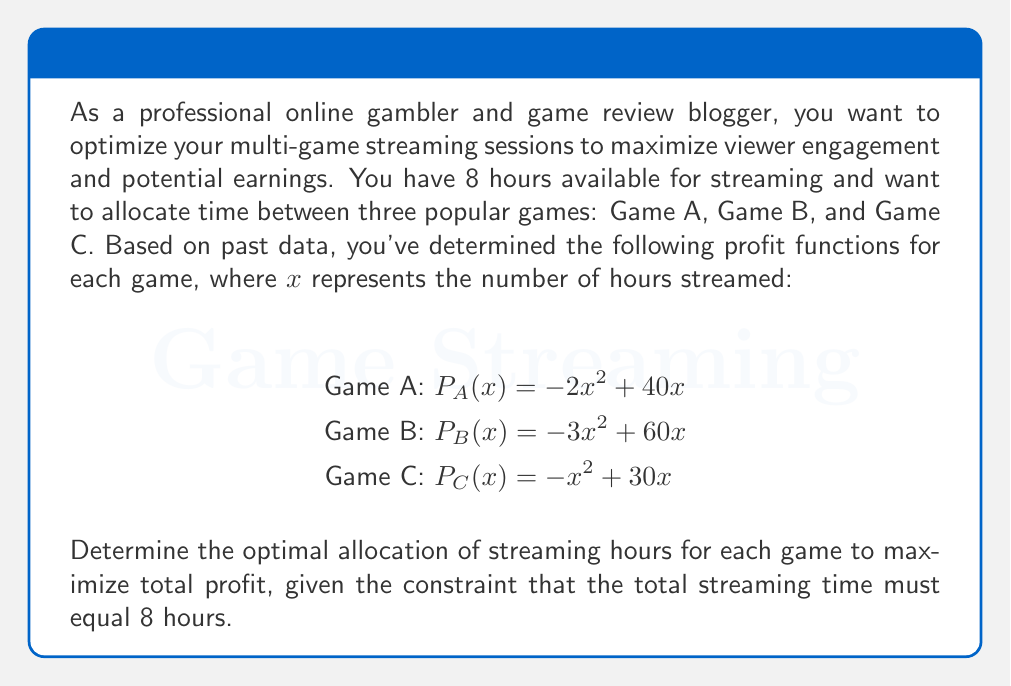Give your solution to this math problem. To solve this optimization problem, we'll use the method of Lagrange multipliers, as we have a constraint on the total streaming time.

1. Let $x$, $y$, and $z$ represent the hours streamed for Games A, B, and C, respectively.

2. Our objective function (total profit) is:
   $$P(x,y,z) = (-2x^2 + 40x) + (-3y^2 + 60y) + (-z^2 + 30z)$$

3. The constraint is:
   $$x + y + z = 8$$

4. Form the Lagrangian function:
   $$L(x,y,z,\lambda) = (-2x^2 + 40x) + (-3y^2 + 60y) + (-z^2 + 30z) + \lambda(8 - x - y - z)$$

5. Take partial derivatives and set them equal to zero:
   $$\frac{\partial L}{\partial x} = -4x + 40 - \lambda = 0$$
   $$\frac{\partial L}{\partial y} = -6y + 60 - \lambda = 0$$
   $$\frac{\partial L}{\partial z} = -2z + 30 - \lambda = 0$$
   $$\frac{\partial L}{\partial \lambda} = 8 - x - y - z = 0$$

6. From these equations, we can derive:
   $$x = 10 - \frac{\lambda}{4}$$
   $$y = 10 - \frac{\lambda}{6}$$
   $$z = 15 - \frac{\lambda}{2}$$

7. Substitute these into the constraint equation:
   $$(10 - \frac{\lambda}{4}) + (10 - \frac{\lambda}{6}) + (15 - \frac{\lambda}{2}) = 8$$

8. Solve for $\lambda$:
   $$35 - \frac{\lambda}{4} - \frac{\lambda}{6} - \frac{\lambda}{2} = 8$$
   $$35 - \frac{3\lambda}{12} - \frac{2\lambda}{12} - \frac{6\lambda}{12} = 8$$
   $$35 - \frac{11\lambda}{12} = 8$$
   $$27 = \frac{11\lambda}{12}$$
   $$\lambda = \frac{324}{11} \approx 29.45$$

9. Substitute this value of $\lambda$ back into the equations for $x$, $y$, and $z$:
   $$x = 10 - \frac{324}{44} \approx 2.64$$
   $$y = 10 - \frac{324}{66} \approx 5.09$$
   $$z = 15 - \frac{324}{22} \approx 0.27$$

10. Round to the nearest tenth of an hour for practicality:
    $x \approx 2.6$ hours, $y \approx 5.1$ hours, $z \approx 0.3$ hours
Answer: The optimal allocation of streaming hours to maximize total profit is approximately:
Game A: 2.6 hours
Game B: 5.1 hours
Game C: 0.3 hours 